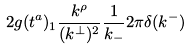<formula> <loc_0><loc_0><loc_500><loc_500>2 g ( t ^ { a } ) _ { 1 } \frac { k ^ { \rho } } { ( k ^ { \bot } ) ^ { 2 } } \frac { 1 } { k _ { - } } 2 \pi \delta ( k ^ { - } )</formula> 